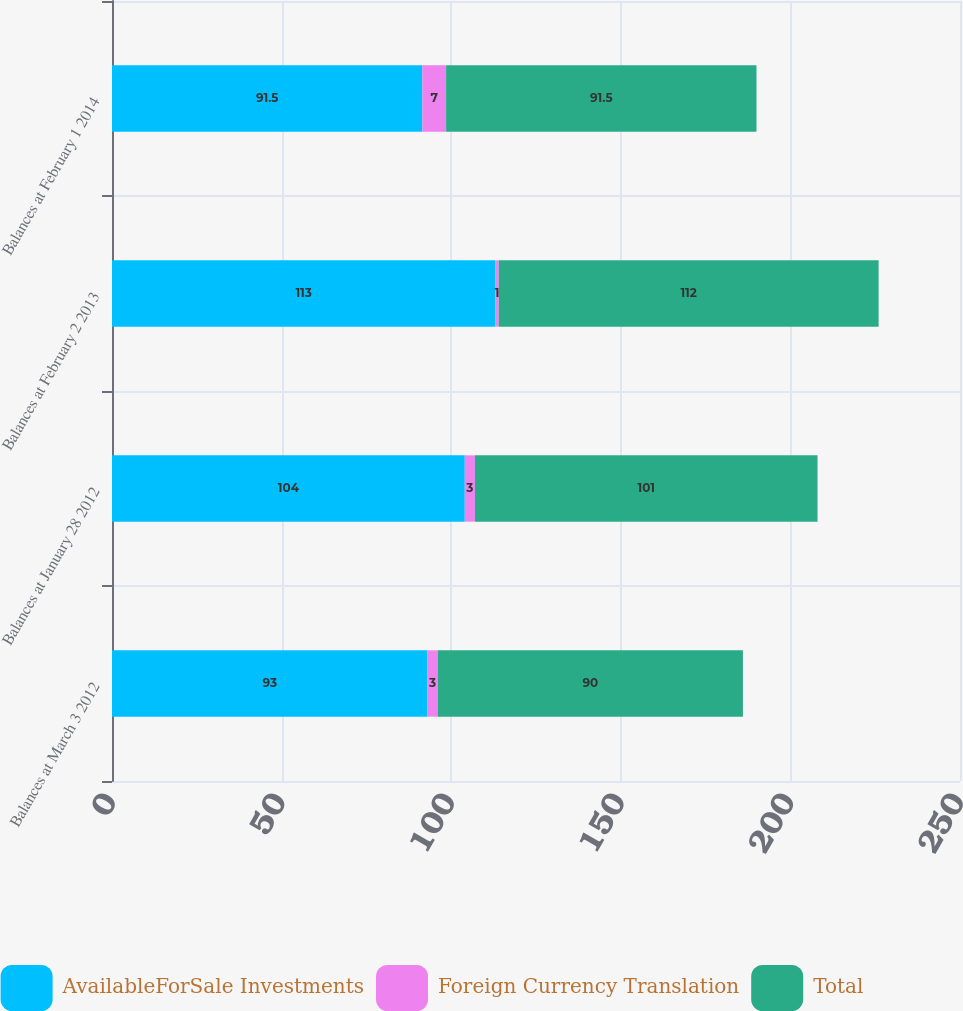Convert chart. <chart><loc_0><loc_0><loc_500><loc_500><stacked_bar_chart><ecel><fcel>Balances at March 3 2012<fcel>Balances at January 28 2012<fcel>Balances at February 2 2013<fcel>Balances at February 1 2014<nl><fcel>AvailableForSale Investments<fcel>93<fcel>104<fcel>113<fcel>91.5<nl><fcel>Foreign Currency Translation<fcel>3<fcel>3<fcel>1<fcel>7<nl><fcel>Total<fcel>90<fcel>101<fcel>112<fcel>91.5<nl></chart> 